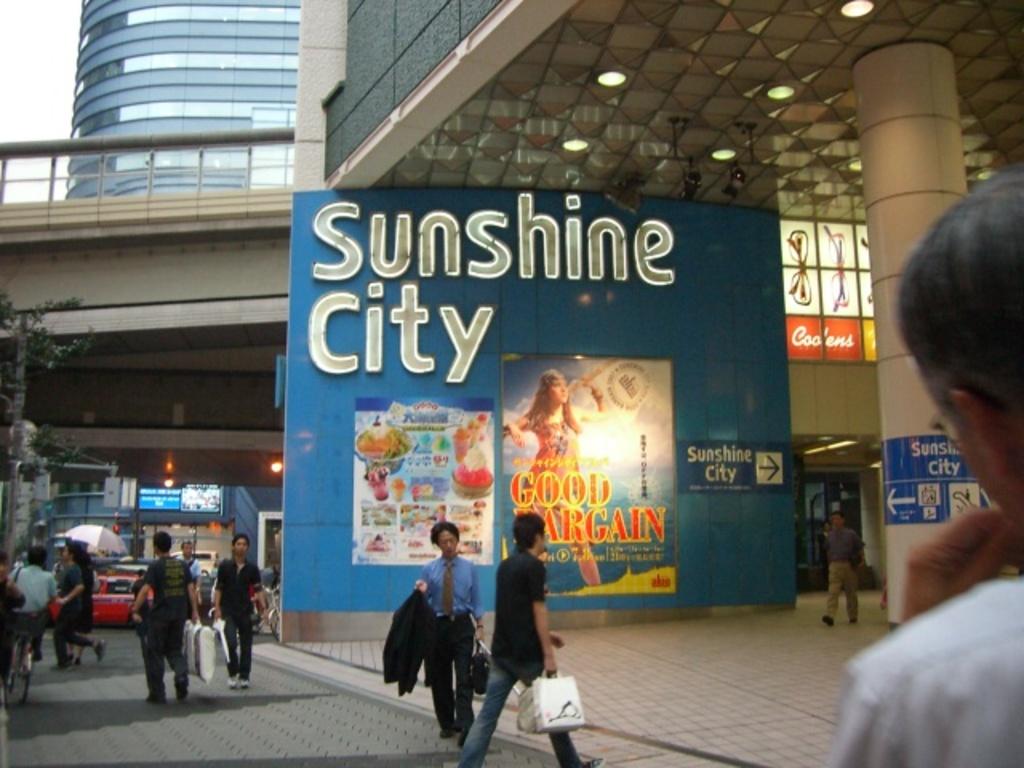What is the city here?
Keep it short and to the point. Sunshine city. What city is advertised on the banner?
Your answer should be very brief. Sunshine city. 